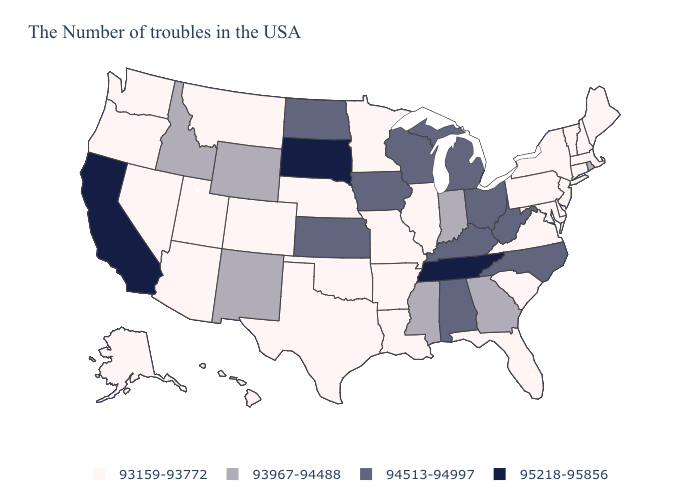Does Wyoming have the lowest value in the USA?
Short answer required. No. Among the states that border Kansas , which have the highest value?
Write a very short answer. Missouri, Nebraska, Oklahoma, Colorado. Does New York have a lower value than Oregon?
Concise answer only. No. What is the value of Michigan?
Concise answer only. 94513-94997. What is the lowest value in the USA?
Answer briefly. 93159-93772. Which states have the lowest value in the Northeast?
Quick response, please. Maine, Massachusetts, New Hampshire, Vermont, Connecticut, New York, New Jersey, Pennsylvania. Name the states that have a value in the range 93967-94488?
Short answer required. Rhode Island, Georgia, Indiana, Mississippi, Wyoming, New Mexico, Idaho. Does West Virginia have the lowest value in the South?
Short answer required. No. Which states hav the highest value in the MidWest?
Write a very short answer. South Dakota. Does South Dakota have the highest value in the USA?
Quick response, please. Yes. Name the states that have a value in the range 93159-93772?
Short answer required. Maine, Massachusetts, New Hampshire, Vermont, Connecticut, New York, New Jersey, Delaware, Maryland, Pennsylvania, Virginia, South Carolina, Florida, Illinois, Louisiana, Missouri, Arkansas, Minnesota, Nebraska, Oklahoma, Texas, Colorado, Utah, Montana, Arizona, Nevada, Washington, Oregon, Alaska, Hawaii. What is the value of Connecticut?
Concise answer only. 93159-93772. What is the highest value in states that border Wyoming?
Keep it brief. 95218-95856. Which states have the lowest value in the USA?
Quick response, please. Maine, Massachusetts, New Hampshire, Vermont, Connecticut, New York, New Jersey, Delaware, Maryland, Pennsylvania, Virginia, South Carolina, Florida, Illinois, Louisiana, Missouri, Arkansas, Minnesota, Nebraska, Oklahoma, Texas, Colorado, Utah, Montana, Arizona, Nevada, Washington, Oregon, Alaska, Hawaii. Which states have the lowest value in the USA?
Short answer required. Maine, Massachusetts, New Hampshire, Vermont, Connecticut, New York, New Jersey, Delaware, Maryland, Pennsylvania, Virginia, South Carolina, Florida, Illinois, Louisiana, Missouri, Arkansas, Minnesota, Nebraska, Oklahoma, Texas, Colorado, Utah, Montana, Arizona, Nevada, Washington, Oregon, Alaska, Hawaii. 